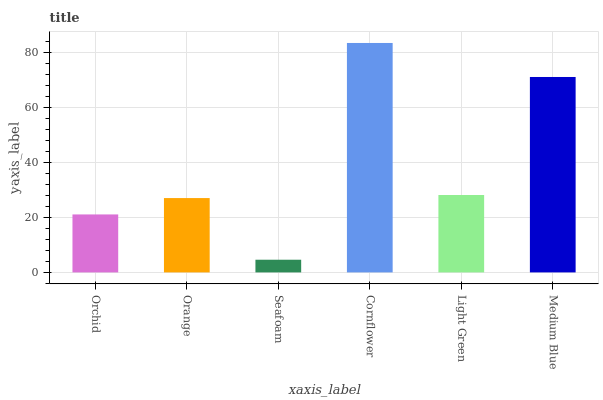Is Orange the minimum?
Answer yes or no. No. Is Orange the maximum?
Answer yes or no. No. Is Orange greater than Orchid?
Answer yes or no. Yes. Is Orchid less than Orange?
Answer yes or no. Yes. Is Orchid greater than Orange?
Answer yes or no. No. Is Orange less than Orchid?
Answer yes or no. No. Is Light Green the high median?
Answer yes or no. Yes. Is Orange the low median?
Answer yes or no. Yes. Is Seafoam the high median?
Answer yes or no. No. Is Seafoam the low median?
Answer yes or no. No. 